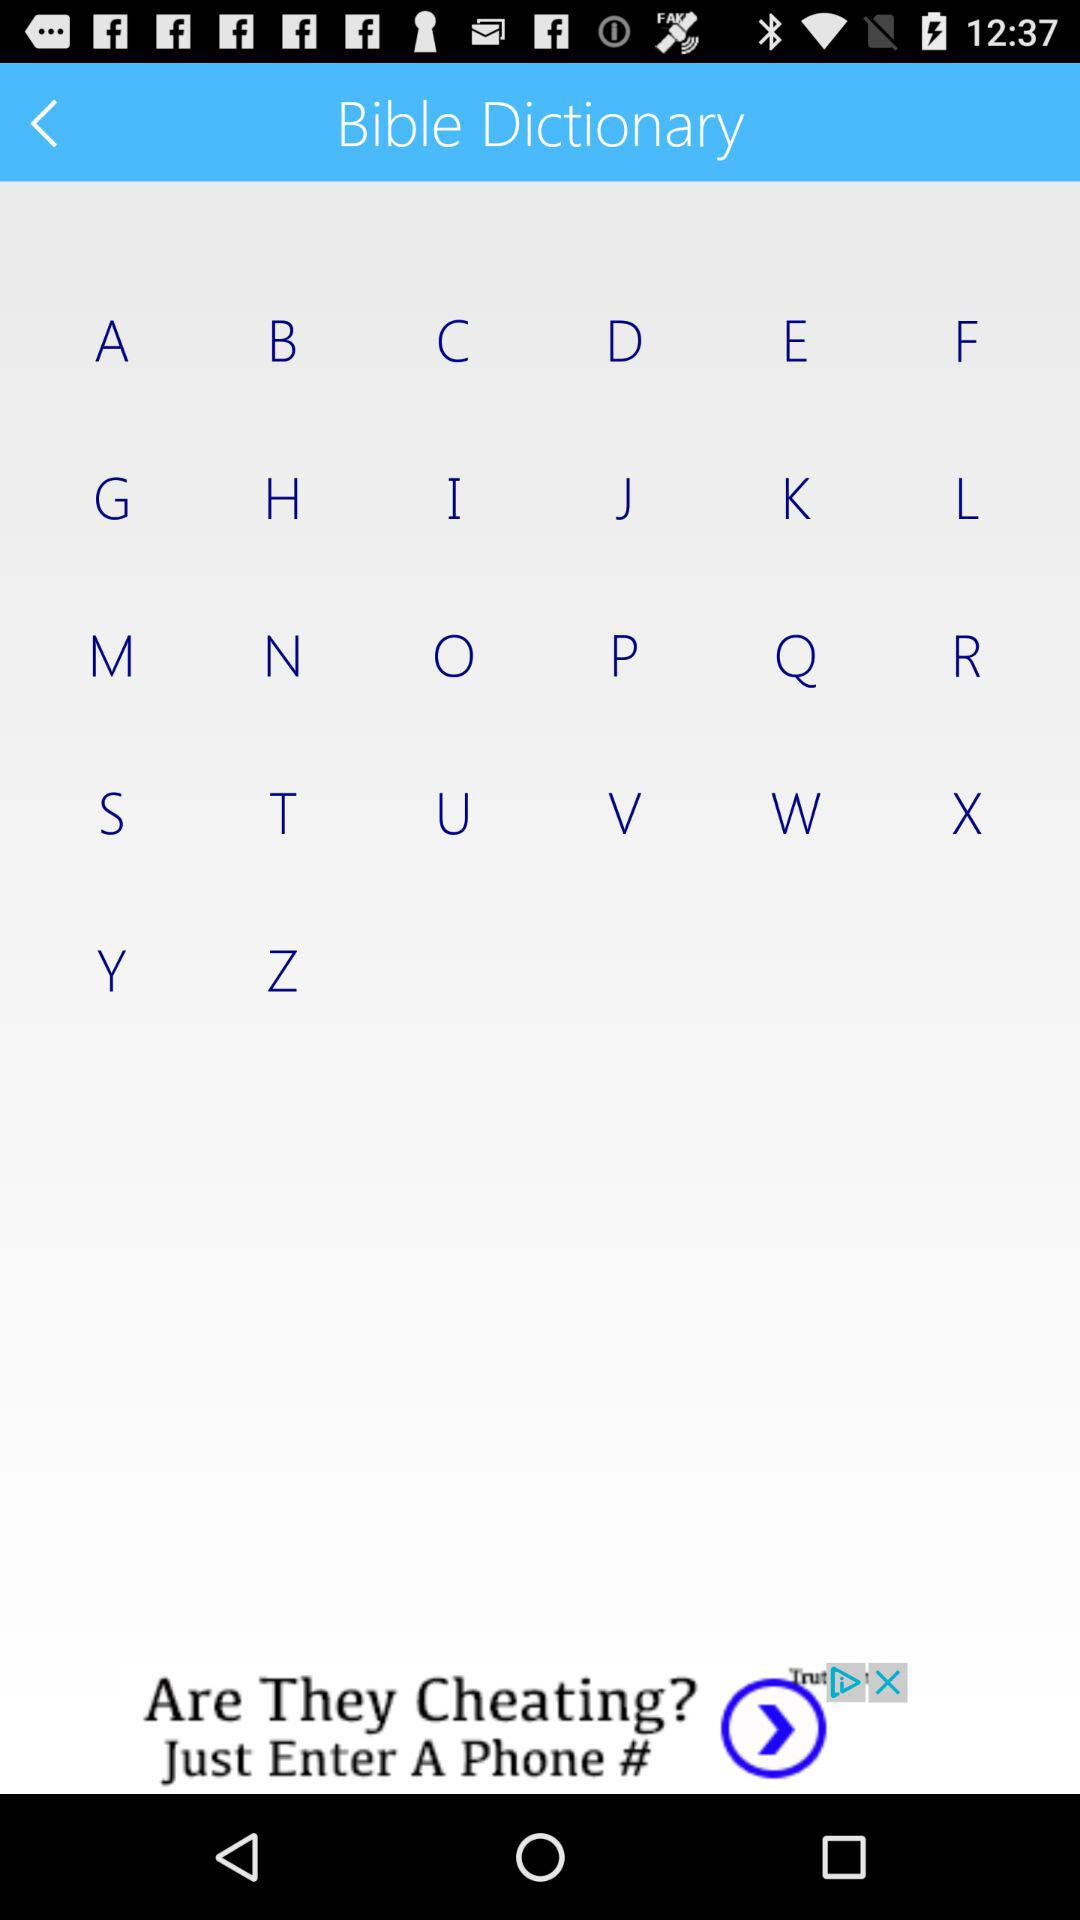What is the application name? The application name is "Bible Dictionary". 